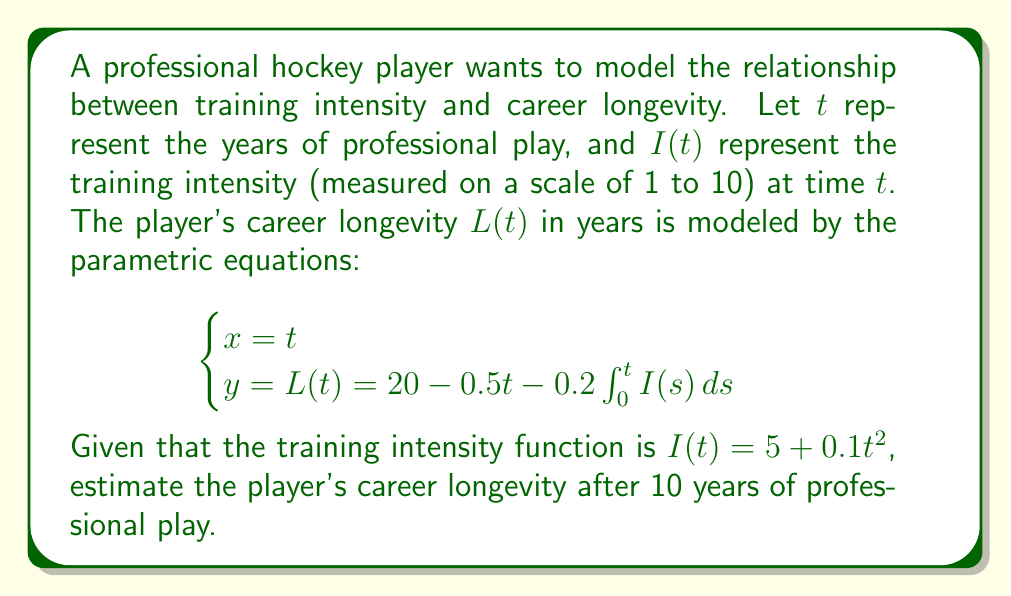Help me with this question. To solve this problem, we need to follow these steps:

1) First, we need to calculate the integral of $I(t)$ from 0 to 10:

   $$\int_0^t I(s) ds = \int_0^t (5 + 0.1s^2) ds$$

2) Evaluating this integral:

   $$\int_0^t (5 + 0.1s^2) ds = 5s + \frac{0.1s^3}{3}\bigg|_0^t = 5t + \frac{0.1t^3}{3}$$

3) Now, we can substitute this into our equation for $L(t)$:

   $$L(t) = 20 - 0.5t - 0.2(5t + \frac{0.1t^3}{3})$$

4) Simplifying:

   $$L(t) = 20 - 0.5t - t - \frac{0.02t^3}{3}$$
   $$L(t) = 20 - 1.5t - \frac{0.02t^3}{3}$$

5) Now, we want to find $L(10)$, so we substitute $t = 10$:

   $$L(10) = 20 - 1.5(10) - \frac{0.02(10^3)}{3}$$
   $$L(10) = 20 - 15 - \frac{20}{3}$$
   $$L(10) = 5 - \frac{20}{3} = \frac{15}{3} - \frac{20}{3} = -\frac{5}{3}$$

6) Since career longevity cannot be negative, we interpret this result as the career ending before the 10-year mark. The exact point where $L(t) = 0$ would give us the precise career longevity.
Answer: The model predicts that the player's career would end before reaching 10 years, with an estimated longevity of 0 years at the 10-year mark. 